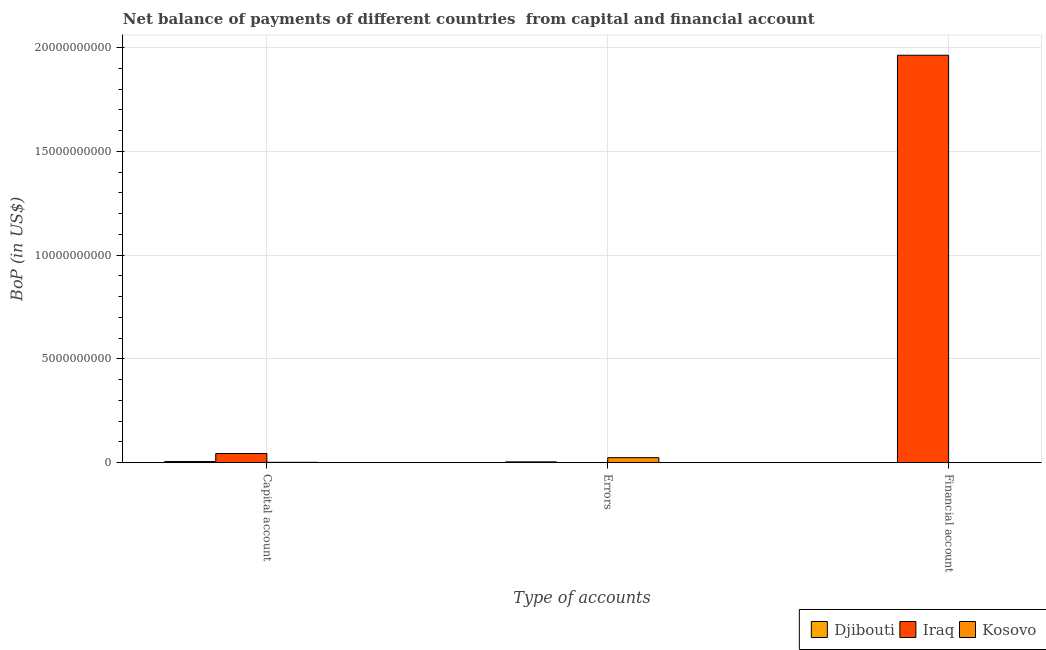How many different coloured bars are there?
Offer a terse response. 3. Are the number of bars on each tick of the X-axis equal?
Your answer should be compact. No. How many bars are there on the 1st tick from the right?
Make the answer very short. 1. What is the label of the 1st group of bars from the left?
Provide a succinct answer. Capital account. What is the amount of financial account in Iraq?
Your answer should be very brief. 1.96e+1. Across all countries, what is the maximum amount of net capital account?
Your answer should be very brief. 4.41e+08. Across all countries, what is the minimum amount of errors?
Make the answer very short. 0. In which country was the amount of financial account maximum?
Your answer should be compact. Iraq. What is the total amount of errors in the graph?
Make the answer very short. 2.78e+08. What is the difference between the amount of net capital account in Djibouti and that in Iraq?
Provide a short and direct response. -3.87e+08. What is the difference between the amount of net capital account in Iraq and the amount of financial account in Djibouti?
Provide a succinct answer. 4.41e+08. What is the average amount of errors per country?
Offer a terse response. 9.28e+07. What is the difference between the amount of errors and amount of net capital account in Djibouti?
Make the answer very short. -1.58e+07. In how many countries, is the amount of financial account greater than 1000000000 US$?
Your answer should be compact. 1. What is the ratio of the amount of net capital account in Djibouti to that in Kosovo?
Make the answer very short. 3.04. Is the amount of net capital account in Djibouti less than that in Kosovo?
Provide a succinct answer. No. What is the difference between the highest and the second highest amount of net capital account?
Give a very brief answer. 3.87e+08. What is the difference between the highest and the lowest amount of net capital account?
Your response must be concise. 4.23e+08. Are the values on the major ticks of Y-axis written in scientific E-notation?
Give a very brief answer. No. Does the graph contain any zero values?
Offer a terse response. Yes. Does the graph contain grids?
Your answer should be very brief. Yes. Where does the legend appear in the graph?
Your response must be concise. Bottom right. How are the legend labels stacked?
Make the answer very short. Horizontal. What is the title of the graph?
Ensure brevity in your answer.  Net balance of payments of different countries  from capital and financial account. What is the label or title of the X-axis?
Offer a very short reply. Type of accounts. What is the label or title of the Y-axis?
Provide a succinct answer. BoP (in US$). What is the BoP (in US$) of Djibouti in Capital account?
Your response must be concise. 5.37e+07. What is the BoP (in US$) in Iraq in Capital account?
Give a very brief answer. 4.41e+08. What is the BoP (in US$) of Kosovo in Capital account?
Provide a succinct answer. 1.77e+07. What is the BoP (in US$) in Djibouti in Errors?
Your response must be concise. 3.79e+07. What is the BoP (in US$) in Kosovo in Errors?
Offer a terse response. 2.41e+08. What is the BoP (in US$) in Iraq in Financial account?
Offer a terse response. 1.96e+1. What is the BoP (in US$) of Kosovo in Financial account?
Keep it short and to the point. 0. Across all Type of accounts, what is the maximum BoP (in US$) in Djibouti?
Provide a short and direct response. 5.37e+07. Across all Type of accounts, what is the maximum BoP (in US$) in Iraq?
Offer a terse response. 1.96e+1. Across all Type of accounts, what is the maximum BoP (in US$) in Kosovo?
Provide a succinct answer. 2.41e+08. Across all Type of accounts, what is the minimum BoP (in US$) of Iraq?
Offer a terse response. 0. Across all Type of accounts, what is the minimum BoP (in US$) in Kosovo?
Ensure brevity in your answer.  0. What is the total BoP (in US$) of Djibouti in the graph?
Offer a very short reply. 9.16e+07. What is the total BoP (in US$) in Iraq in the graph?
Ensure brevity in your answer.  2.01e+1. What is the total BoP (in US$) in Kosovo in the graph?
Offer a very short reply. 2.58e+08. What is the difference between the BoP (in US$) of Djibouti in Capital account and that in Errors?
Offer a terse response. 1.58e+07. What is the difference between the BoP (in US$) in Kosovo in Capital account and that in Errors?
Make the answer very short. -2.23e+08. What is the difference between the BoP (in US$) of Iraq in Capital account and that in Financial account?
Ensure brevity in your answer.  -1.92e+1. What is the difference between the BoP (in US$) in Djibouti in Capital account and the BoP (in US$) in Kosovo in Errors?
Give a very brief answer. -1.87e+08. What is the difference between the BoP (in US$) of Iraq in Capital account and the BoP (in US$) of Kosovo in Errors?
Your answer should be compact. 2.00e+08. What is the difference between the BoP (in US$) in Djibouti in Capital account and the BoP (in US$) in Iraq in Financial account?
Your answer should be very brief. -1.96e+1. What is the difference between the BoP (in US$) in Djibouti in Errors and the BoP (in US$) in Iraq in Financial account?
Provide a succinct answer. -1.96e+1. What is the average BoP (in US$) in Djibouti per Type of accounts?
Ensure brevity in your answer.  3.05e+07. What is the average BoP (in US$) of Iraq per Type of accounts?
Your answer should be very brief. 6.69e+09. What is the average BoP (in US$) in Kosovo per Type of accounts?
Make the answer very short. 8.61e+07. What is the difference between the BoP (in US$) in Djibouti and BoP (in US$) in Iraq in Capital account?
Make the answer very short. -3.87e+08. What is the difference between the BoP (in US$) in Djibouti and BoP (in US$) in Kosovo in Capital account?
Your response must be concise. 3.61e+07. What is the difference between the BoP (in US$) in Iraq and BoP (in US$) in Kosovo in Capital account?
Your response must be concise. 4.23e+08. What is the difference between the BoP (in US$) in Djibouti and BoP (in US$) in Kosovo in Errors?
Your answer should be very brief. -2.03e+08. What is the ratio of the BoP (in US$) in Djibouti in Capital account to that in Errors?
Your answer should be very brief. 1.42. What is the ratio of the BoP (in US$) of Kosovo in Capital account to that in Errors?
Make the answer very short. 0.07. What is the ratio of the BoP (in US$) in Iraq in Capital account to that in Financial account?
Provide a succinct answer. 0.02. What is the difference between the highest and the lowest BoP (in US$) of Djibouti?
Provide a succinct answer. 5.37e+07. What is the difference between the highest and the lowest BoP (in US$) of Iraq?
Offer a terse response. 1.96e+1. What is the difference between the highest and the lowest BoP (in US$) in Kosovo?
Make the answer very short. 2.41e+08. 